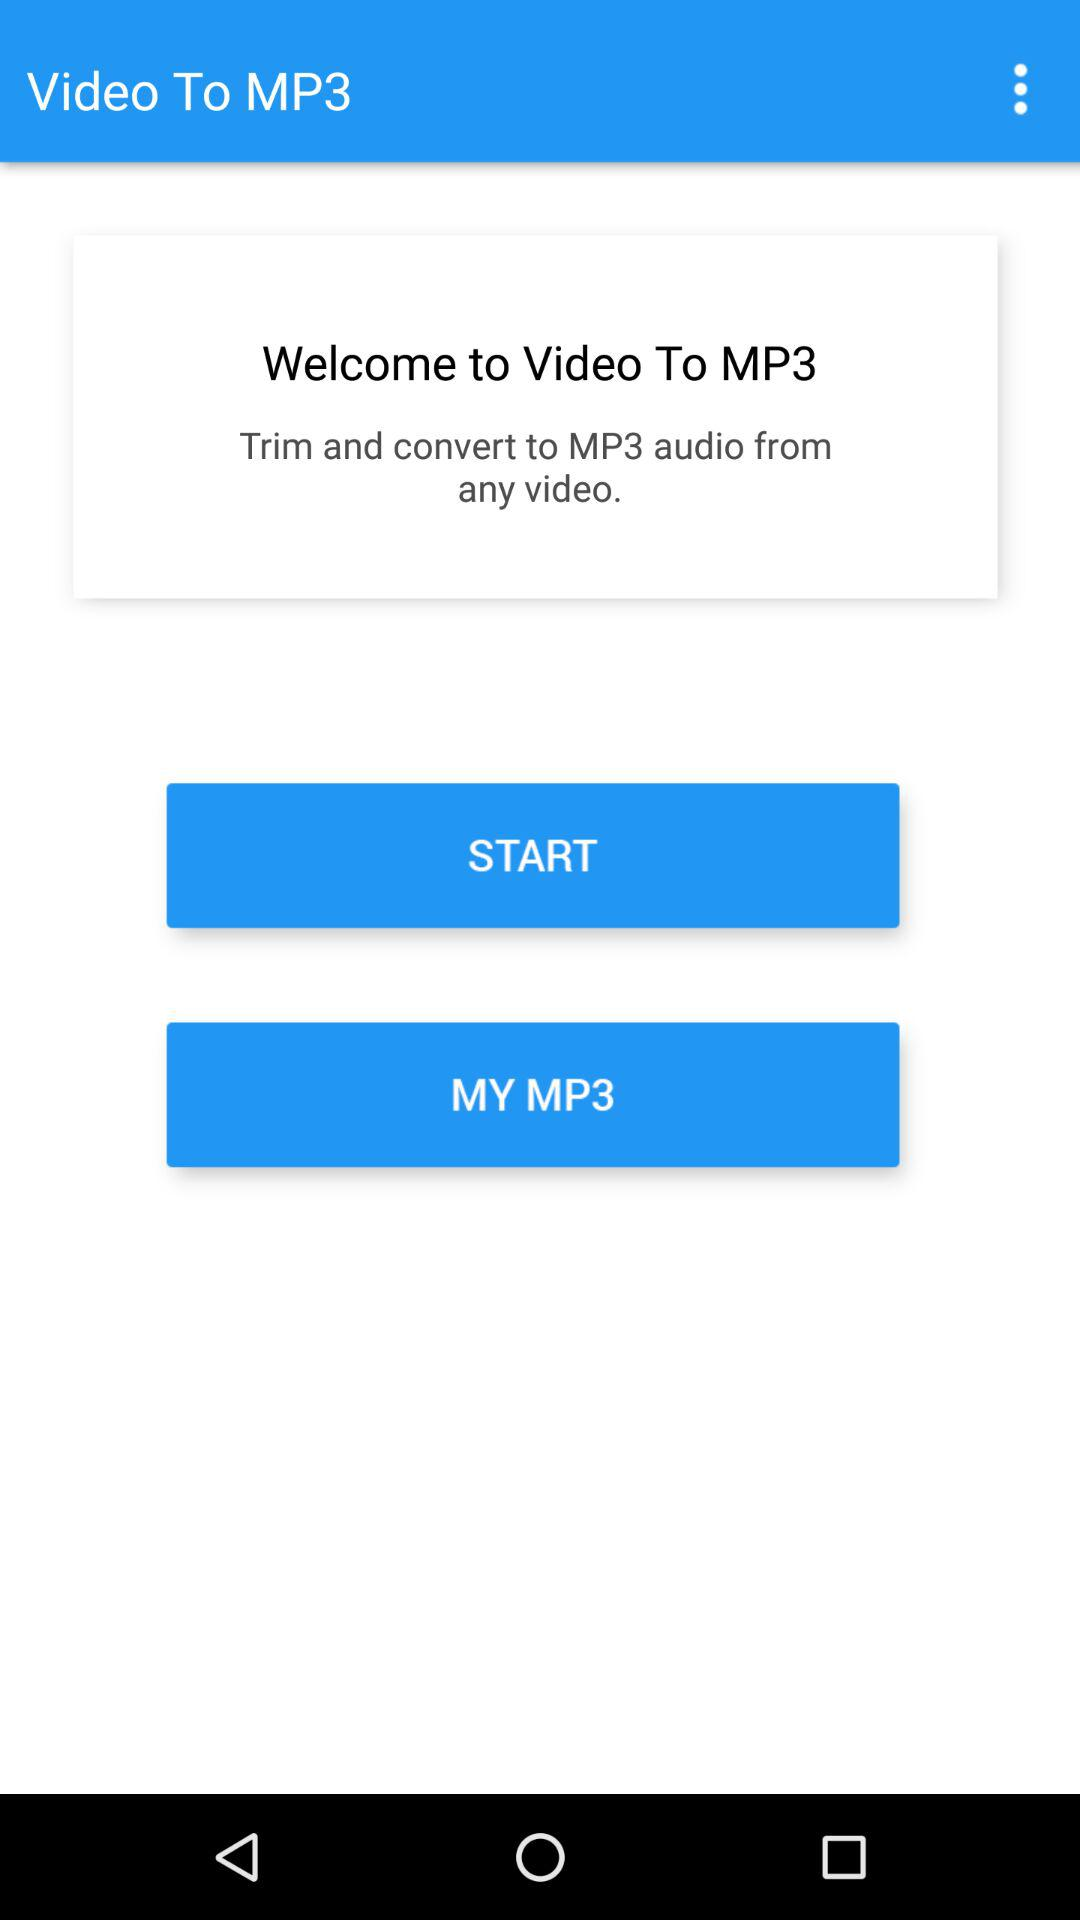What is the application name? The application name is "Video To MP3". 